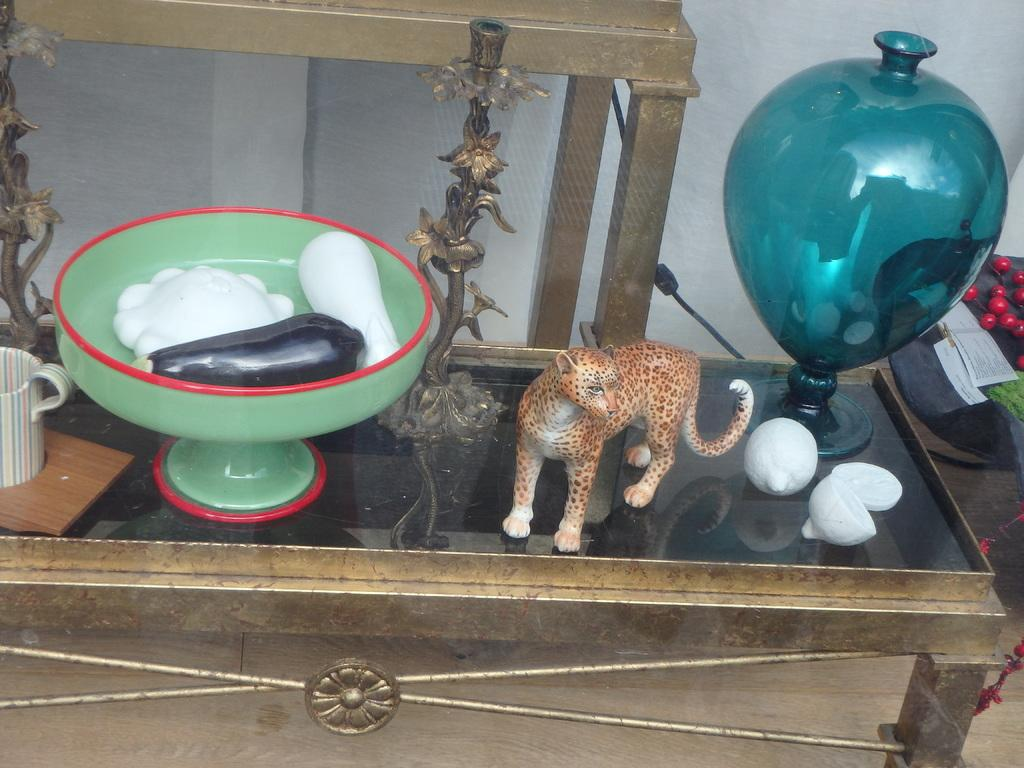What type of furniture is present in the image? There is a table in the image. What is placed on the table? There is a cup, standings, a tiger statue, a green color container with some things in it, and a blue color showpiece on the table. Can you describe the tiger statue? The tiger statue is present on the table. What color is the showpiece on the table? The showpiece on the table is blue. What type of cake is being served on the canvas in the image? There is no cake or canvas present in the image; the items mentioned are a table, cup, standings, tiger statue, green container, and blue showpiece. 